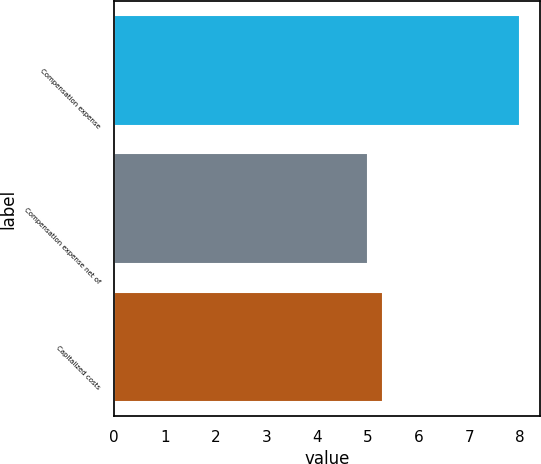<chart> <loc_0><loc_0><loc_500><loc_500><bar_chart><fcel>Compensation expense<fcel>Compensation expense net of<fcel>Capitalized costs<nl><fcel>8<fcel>5<fcel>5.3<nl></chart> 